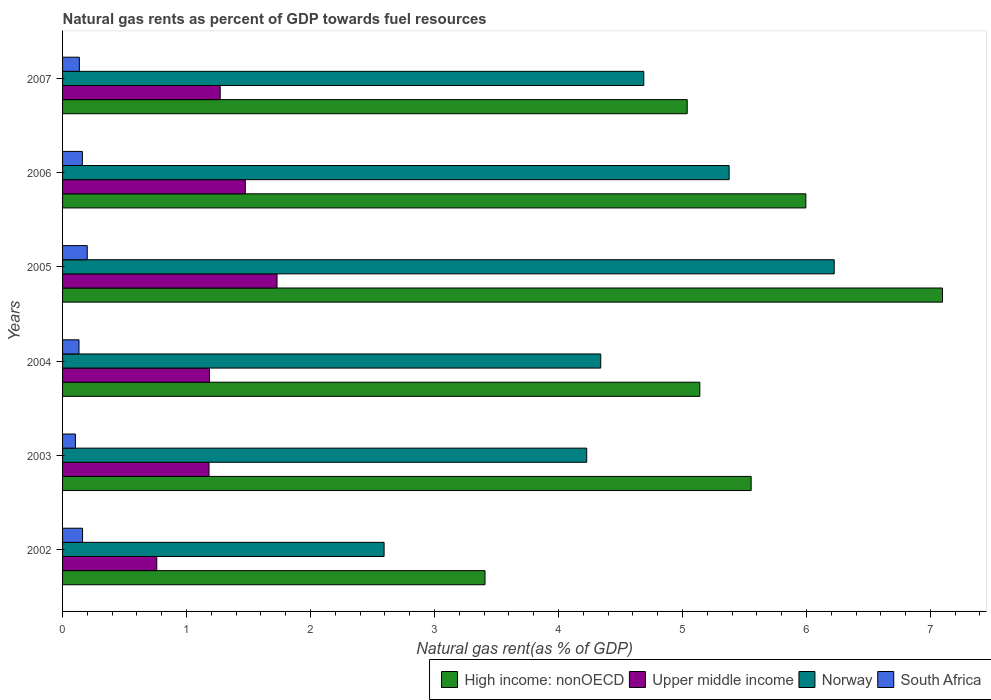How many groups of bars are there?
Make the answer very short. 6. Are the number of bars per tick equal to the number of legend labels?
Your answer should be compact. Yes. How many bars are there on the 6th tick from the top?
Keep it short and to the point. 4. How many bars are there on the 3rd tick from the bottom?
Give a very brief answer. 4. In how many cases, is the number of bars for a given year not equal to the number of legend labels?
Provide a short and direct response. 0. What is the natural gas rent in Norway in 2004?
Make the answer very short. 4.34. Across all years, what is the maximum natural gas rent in South Africa?
Your response must be concise. 0.2. Across all years, what is the minimum natural gas rent in Norway?
Provide a short and direct response. 2.59. In which year was the natural gas rent in Upper middle income maximum?
Provide a succinct answer. 2005. What is the total natural gas rent in Upper middle income in the graph?
Your answer should be compact. 7.6. What is the difference between the natural gas rent in Norway in 2002 and that in 2003?
Provide a succinct answer. -1.63. What is the difference between the natural gas rent in High income: nonOECD in 2004 and the natural gas rent in Norway in 2005?
Provide a succinct answer. -1.08. What is the average natural gas rent in Norway per year?
Make the answer very short. 4.58. In the year 2007, what is the difference between the natural gas rent in High income: nonOECD and natural gas rent in South Africa?
Offer a terse response. 4.9. In how many years, is the natural gas rent in South Africa greater than 2.6 %?
Ensure brevity in your answer.  0. What is the ratio of the natural gas rent in Norway in 2003 to that in 2006?
Provide a succinct answer. 0.79. Is the natural gas rent in Upper middle income in 2002 less than that in 2007?
Give a very brief answer. Yes. Is the difference between the natural gas rent in High income: nonOECD in 2004 and 2006 greater than the difference between the natural gas rent in South Africa in 2004 and 2006?
Provide a short and direct response. No. What is the difference between the highest and the second highest natural gas rent in Upper middle income?
Your answer should be compact. 0.26. What is the difference between the highest and the lowest natural gas rent in Norway?
Provide a succinct answer. 3.63. What does the 1st bar from the top in 2006 represents?
Make the answer very short. South Africa. What does the 1st bar from the bottom in 2003 represents?
Offer a terse response. High income: nonOECD. How many bars are there?
Your answer should be very brief. 24. How many years are there in the graph?
Ensure brevity in your answer.  6. Are the values on the major ticks of X-axis written in scientific E-notation?
Provide a succinct answer. No. Does the graph contain grids?
Make the answer very short. No. How many legend labels are there?
Ensure brevity in your answer.  4. What is the title of the graph?
Your answer should be compact. Natural gas rents as percent of GDP towards fuel resources. What is the label or title of the X-axis?
Offer a terse response. Natural gas rent(as % of GDP). What is the Natural gas rent(as % of GDP) in High income: nonOECD in 2002?
Provide a short and direct response. 3.41. What is the Natural gas rent(as % of GDP) of Upper middle income in 2002?
Your response must be concise. 0.76. What is the Natural gas rent(as % of GDP) of Norway in 2002?
Make the answer very short. 2.59. What is the Natural gas rent(as % of GDP) in South Africa in 2002?
Provide a succinct answer. 0.16. What is the Natural gas rent(as % of GDP) of High income: nonOECD in 2003?
Your answer should be very brief. 5.55. What is the Natural gas rent(as % of GDP) in Upper middle income in 2003?
Make the answer very short. 1.18. What is the Natural gas rent(as % of GDP) of Norway in 2003?
Make the answer very short. 4.23. What is the Natural gas rent(as % of GDP) in South Africa in 2003?
Provide a short and direct response. 0.1. What is the Natural gas rent(as % of GDP) of High income: nonOECD in 2004?
Make the answer very short. 5.14. What is the Natural gas rent(as % of GDP) of Upper middle income in 2004?
Give a very brief answer. 1.19. What is the Natural gas rent(as % of GDP) of Norway in 2004?
Provide a succinct answer. 4.34. What is the Natural gas rent(as % of GDP) of South Africa in 2004?
Offer a very short reply. 0.13. What is the Natural gas rent(as % of GDP) in High income: nonOECD in 2005?
Your response must be concise. 7.1. What is the Natural gas rent(as % of GDP) in Upper middle income in 2005?
Offer a terse response. 1.73. What is the Natural gas rent(as % of GDP) in Norway in 2005?
Provide a short and direct response. 6.22. What is the Natural gas rent(as % of GDP) of South Africa in 2005?
Your answer should be compact. 0.2. What is the Natural gas rent(as % of GDP) in High income: nonOECD in 2006?
Provide a succinct answer. 6. What is the Natural gas rent(as % of GDP) of Upper middle income in 2006?
Make the answer very short. 1.47. What is the Natural gas rent(as % of GDP) of Norway in 2006?
Provide a short and direct response. 5.38. What is the Natural gas rent(as % of GDP) of South Africa in 2006?
Provide a succinct answer. 0.16. What is the Natural gas rent(as % of GDP) of High income: nonOECD in 2007?
Give a very brief answer. 5.04. What is the Natural gas rent(as % of GDP) of Upper middle income in 2007?
Provide a succinct answer. 1.27. What is the Natural gas rent(as % of GDP) of Norway in 2007?
Make the answer very short. 4.69. What is the Natural gas rent(as % of GDP) in South Africa in 2007?
Your answer should be compact. 0.14. Across all years, what is the maximum Natural gas rent(as % of GDP) in High income: nonOECD?
Give a very brief answer. 7.1. Across all years, what is the maximum Natural gas rent(as % of GDP) in Upper middle income?
Offer a very short reply. 1.73. Across all years, what is the maximum Natural gas rent(as % of GDP) of Norway?
Offer a terse response. 6.22. Across all years, what is the maximum Natural gas rent(as % of GDP) of South Africa?
Your response must be concise. 0.2. Across all years, what is the minimum Natural gas rent(as % of GDP) in High income: nonOECD?
Offer a very short reply. 3.41. Across all years, what is the minimum Natural gas rent(as % of GDP) in Upper middle income?
Your response must be concise. 0.76. Across all years, what is the minimum Natural gas rent(as % of GDP) of Norway?
Keep it short and to the point. 2.59. Across all years, what is the minimum Natural gas rent(as % of GDP) of South Africa?
Offer a terse response. 0.1. What is the total Natural gas rent(as % of GDP) of High income: nonOECD in the graph?
Offer a very short reply. 32.23. What is the total Natural gas rent(as % of GDP) of Upper middle income in the graph?
Your answer should be very brief. 7.6. What is the total Natural gas rent(as % of GDP) in Norway in the graph?
Offer a terse response. 27.45. What is the total Natural gas rent(as % of GDP) in South Africa in the graph?
Your answer should be compact. 0.89. What is the difference between the Natural gas rent(as % of GDP) of High income: nonOECD in 2002 and that in 2003?
Provide a succinct answer. -2.15. What is the difference between the Natural gas rent(as % of GDP) of Upper middle income in 2002 and that in 2003?
Ensure brevity in your answer.  -0.42. What is the difference between the Natural gas rent(as % of GDP) of Norway in 2002 and that in 2003?
Provide a succinct answer. -1.63. What is the difference between the Natural gas rent(as % of GDP) in South Africa in 2002 and that in 2003?
Provide a succinct answer. 0.06. What is the difference between the Natural gas rent(as % of GDP) in High income: nonOECD in 2002 and that in 2004?
Ensure brevity in your answer.  -1.73. What is the difference between the Natural gas rent(as % of GDP) of Upper middle income in 2002 and that in 2004?
Ensure brevity in your answer.  -0.43. What is the difference between the Natural gas rent(as % of GDP) of Norway in 2002 and that in 2004?
Provide a succinct answer. -1.75. What is the difference between the Natural gas rent(as % of GDP) of South Africa in 2002 and that in 2004?
Make the answer very short. 0.03. What is the difference between the Natural gas rent(as % of GDP) of High income: nonOECD in 2002 and that in 2005?
Provide a short and direct response. -3.69. What is the difference between the Natural gas rent(as % of GDP) in Upper middle income in 2002 and that in 2005?
Provide a short and direct response. -0.97. What is the difference between the Natural gas rent(as % of GDP) in Norway in 2002 and that in 2005?
Give a very brief answer. -3.63. What is the difference between the Natural gas rent(as % of GDP) of South Africa in 2002 and that in 2005?
Your answer should be very brief. -0.04. What is the difference between the Natural gas rent(as % of GDP) in High income: nonOECD in 2002 and that in 2006?
Offer a very short reply. -2.59. What is the difference between the Natural gas rent(as % of GDP) of Upper middle income in 2002 and that in 2006?
Give a very brief answer. -0.71. What is the difference between the Natural gas rent(as % of GDP) of Norway in 2002 and that in 2006?
Your answer should be very brief. -2.78. What is the difference between the Natural gas rent(as % of GDP) in South Africa in 2002 and that in 2006?
Your answer should be very brief. 0. What is the difference between the Natural gas rent(as % of GDP) of High income: nonOECD in 2002 and that in 2007?
Provide a short and direct response. -1.63. What is the difference between the Natural gas rent(as % of GDP) in Upper middle income in 2002 and that in 2007?
Ensure brevity in your answer.  -0.51. What is the difference between the Natural gas rent(as % of GDP) in Norway in 2002 and that in 2007?
Offer a very short reply. -2.09. What is the difference between the Natural gas rent(as % of GDP) in South Africa in 2002 and that in 2007?
Keep it short and to the point. 0.03. What is the difference between the Natural gas rent(as % of GDP) of High income: nonOECD in 2003 and that in 2004?
Your answer should be very brief. 0.41. What is the difference between the Natural gas rent(as % of GDP) of Upper middle income in 2003 and that in 2004?
Your answer should be very brief. -0. What is the difference between the Natural gas rent(as % of GDP) in Norway in 2003 and that in 2004?
Your answer should be compact. -0.11. What is the difference between the Natural gas rent(as % of GDP) of South Africa in 2003 and that in 2004?
Your answer should be very brief. -0.03. What is the difference between the Natural gas rent(as % of GDP) of High income: nonOECD in 2003 and that in 2005?
Keep it short and to the point. -1.54. What is the difference between the Natural gas rent(as % of GDP) in Upper middle income in 2003 and that in 2005?
Give a very brief answer. -0.55. What is the difference between the Natural gas rent(as % of GDP) of Norway in 2003 and that in 2005?
Provide a succinct answer. -2. What is the difference between the Natural gas rent(as % of GDP) of South Africa in 2003 and that in 2005?
Make the answer very short. -0.1. What is the difference between the Natural gas rent(as % of GDP) of High income: nonOECD in 2003 and that in 2006?
Your answer should be very brief. -0.44. What is the difference between the Natural gas rent(as % of GDP) of Upper middle income in 2003 and that in 2006?
Provide a short and direct response. -0.29. What is the difference between the Natural gas rent(as % of GDP) in Norway in 2003 and that in 2006?
Offer a very short reply. -1.15. What is the difference between the Natural gas rent(as % of GDP) in South Africa in 2003 and that in 2006?
Your answer should be very brief. -0.06. What is the difference between the Natural gas rent(as % of GDP) of High income: nonOECD in 2003 and that in 2007?
Offer a very short reply. 0.52. What is the difference between the Natural gas rent(as % of GDP) of Upper middle income in 2003 and that in 2007?
Provide a short and direct response. -0.09. What is the difference between the Natural gas rent(as % of GDP) in Norway in 2003 and that in 2007?
Keep it short and to the point. -0.46. What is the difference between the Natural gas rent(as % of GDP) in South Africa in 2003 and that in 2007?
Your answer should be very brief. -0.03. What is the difference between the Natural gas rent(as % of GDP) in High income: nonOECD in 2004 and that in 2005?
Provide a succinct answer. -1.96. What is the difference between the Natural gas rent(as % of GDP) of Upper middle income in 2004 and that in 2005?
Offer a terse response. -0.54. What is the difference between the Natural gas rent(as % of GDP) of Norway in 2004 and that in 2005?
Provide a succinct answer. -1.88. What is the difference between the Natural gas rent(as % of GDP) in South Africa in 2004 and that in 2005?
Make the answer very short. -0.07. What is the difference between the Natural gas rent(as % of GDP) in High income: nonOECD in 2004 and that in 2006?
Your answer should be very brief. -0.86. What is the difference between the Natural gas rent(as % of GDP) of Upper middle income in 2004 and that in 2006?
Give a very brief answer. -0.29. What is the difference between the Natural gas rent(as % of GDP) of Norway in 2004 and that in 2006?
Your answer should be compact. -1.04. What is the difference between the Natural gas rent(as % of GDP) of South Africa in 2004 and that in 2006?
Offer a terse response. -0.03. What is the difference between the Natural gas rent(as % of GDP) of High income: nonOECD in 2004 and that in 2007?
Make the answer very short. 0.1. What is the difference between the Natural gas rent(as % of GDP) in Upper middle income in 2004 and that in 2007?
Offer a terse response. -0.09. What is the difference between the Natural gas rent(as % of GDP) in Norway in 2004 and that in 2007?
Provide a short and direct response. -0.35. What is the difference between the Natural gas rent(as % of GDP) in South Africa in 2004 and that in 2007?
Provide a short and direct response. -0. What is the difference between the Natural gas rent(as % of GDP) of High income: nonOECD in 2005 and that in 2006?
Provide a short and direct response. 1.1. What is the difference between the Natural gas rent(as % of GDP) of Upper middle income in 2005 and that in 2006?
Your response must be concise. 0.26. What is the difference between the Natural gas rent(as % of GDP) of Norway in 2005 and that in 2006?
Offer a terse response. 0.85. What is the difference between the Natural gas rent(as % of GDP) in South Africa in 2005 and that in 2006?
Make the answer very short. 0.04. What is the difference between the Natural gas rent(as % of GDP) in High income: nonOECD in 2005 and that in 2007?
Keep it short and to the point. 2.06. What is the difference between the Natural gas rent(as % of GDP) in Upper middle income in 2005 and that in 2007?
Provide a short and direct response. 0.46. What is the difference between the Natural gas rent(as % of GDP) in Norway in 2005 and that in 2007?
Provide a succinct answer. 1.54. What is the difference between the Natural gas rent(as % of GDP) of South Africa in 2005 and that in 2007?
Provide a succinct answer. 0.06. What is the difference between the Natural gas rent(as % of GDP) in Upper middle income in 2006 and that in 2007?
Give a very brief answer. 0.2. What is the difference between the Natural gas rent(as % of GDP) in Norway in 2006 and that in 2007?
Offer a very short reply. 0.69. What is the difference between the Natural gas rent(as % of GDP) in South Africa in 2006 and that in 2007?
Make the answer very short. 0.02. What is the difference between the Natural gas rent(as % of GDP) in High income: nonOECD in 2002 and the Natural gas rent(as % of GDP) in Upper middle income in 2003?
Provide a succinct answer. 2.23. What is the difference between the Natural gas rent(as % of GDP) in High income: nonOECD in 2002 and the Natural gas rent(as % of GDP) in Norway in 2003?
Your answer should be very brief. -0.82. What is the difference between the Natural gas rent(as % of GDP) in High income: nonOECD in 2002 and the Natural gas rent(as % of GDP) in South Africa in 2003?
Offer a terse response. 3.3. What is the difference between the Natural gas rent(as % of GDP) of Upper middle income in 2002 and the Natural gas rent(as % of GDP) of Norway in 2003?
Your answer should be compact. -3.47. What is the difference between the Natural gas rent(as % of GDP) in Upper middle income in 2002 and the Natural gas rent(as % of GDP) in South Africa in 2003?
Keep it short and to the point. 0.66. What is the difference between the Natural gas rent(as % of GDP) of Norway in 2002 and the Natural gas rent(as % of GDP) of South Africa in 2003?
Your response must be concise. 2.49. What is the difference between the Natural gas rent(as % of GDP) of High income: nonOECD in 2002 and the Natural gas rent(as % of GDP) of Upper middle income in 2004?
Keep it short and to the point. 2.22. What is the difference between the Natural gas rent(as % of GDP) of High income: nonOECD in 2002 and the Natural gas rent(as % of GDP) of Norway in 2004?
Your answer should be compact. -0.93. What is the difference between the Natural gas rent(as % of GDP) of High income: nonOECD in 2002 and the Natural gas rent(as % of GDP) of South Africa in 2004?
Your answer should be compact. 3.27. What is the difference between the Natural gas rent(as % of GDP) of Upper middle income in 2002 and the Natural gas rent(as % of GDP) of Norway in 2004?
Your response must be concise. -3.58. What is the difference between the Natural gas rent(as % of GDP) of Upper middle income in 2002 and the Natural gas rent(as % of GDP) of South Africa in 2004?
Give a very brief answer. 0.63. What is the difference between the Natural gas rent(as % of GDP) of Norway in 2002 and the Natural gas rent(as % of GDP) of South Africa in 2004?
Your answer should be very brief. 2.46. What is the difference between the Natural gas rent(as % of GDP) in High income: nonOECD in 2002 and the Natural gas rent(as % of GDP) in Upper middle income in 2005?
Keep it short and to the point. 1.68. What is the difference between the Natural gas rent(as % of GDP) in High income: nonOECD in 2002 and the Natural gas rent(as % of GDP) in Norway in 2005?
Offer a very short reply. -2.82. What is the difference between the Natural gas rent(as % of GDP) in High income: nonOECD in 2002 and the Natural gas rent(as % of GDP) in South Africa in 2005?
Ensure brevity in your answer.  3.21. What is the difference between the Natural gas rent(as % of GDP) in Upper middle income in 2002 and the Natural gas rent(as % of GDP) in Norway in 2005?
Keep it short and to the point. -5.46. What is the difference between the Natural gas rent(as % of GDP) of Upper middle income in 2002 and the Natural gas rent(as % of GDP) of South Africa in 2005?
Provide a succinct answer. 0.56. What is the difference between the Natural gas rent(as % of GDP) of Norway in 2002 and the Natural gas rent(as % of GDP) of South Africa in 2005?
Your response must be concise. 2.39. What is the difference between the Natural gas rent(as % of GDP) in High income: nonOECD in 2002 and the Natural gas rent(as % of GDP) in Upper middle income in 2006?
Offer a terse response. 1.93. What is the difference between the Natural gas rent(as % of GDP) in High income: nonOECD in 2002 and the Natural gas rent(as % of GDP) in Norway in 2006?
Make the answer very short. -1.97. What is the difference between the Natural gas rent(as % of GDP) of High income: nonOECD in 2002 and the Natural gas rent(as % of GDP) of South Africa in 2006?
Offer a very short reply. 3.25. What is the difference between the Natural gas rent(as % of GDP) of Upper middle income in 2002 and the Natural gas rent(as % of GDP) of Norway in 2006?
Keep it short and to the point. -4.62. What is the difference between the Natural gas rent(as % of GDP) of Upper middle income in 2002 and the Natural gas rent(as % of GDP) of South Africa in 2006?
Your answer should be very brief. 0.6. What is the difference between the Natural gas rent(as % of GDP) in Norway in 2002 and the Natural gas rent(as % of GDP) in South Africa in 2006?
Your response must be concise. 2.43. What is the difference between the Natural gas rent(as % of GDP) of High income: nonOECD in 2002 and the Natural gas rent(as % of GDP) of Upper middle income in 2007?
Your answer should be compact. 2.14. What is the difference between the Natural gas rent(as % of GDP) of High income: nonOECD in 2002 and the Natural gas rent(as % of GDP) of Norway in 2007?
Your response must be concise. -1.28. What is the difference between the Natural gas rent(as % of GDP) of High income: nonOECD in 2002 and the Natural gas rent(as % of GDP) of South Africa in 2007?
Make the answer very short. 3.27. What is the difference between the Natural gas rent(as % of GDP) of Upper middle income in 2002 and the Natural gas rent(as % of GDP) of Norway in 2007?
Offer a very short reply. -3.93. What is the difference between the Natural gas rent(as % of GDP) in Upper middle income in 2002 and the Natural gas rent(as % of GDP) in South Africa in 2007?
Ensure brevity in your answer.  0.62. What is the difference between the Natural gas rent(as % of GDP) in Norway in 2002 and the Natural gas rent(as % of GDP) in South Africa in 2007?
Give a very brief answer. 2.46. What is the difference between the Natural gas rent(as % of GDP) of High income: nonOECD in 2003 and the Natural gas rent(as % of GDP) of Upper middle income in 2004?
Your answer should be compact. 4.37. What is the difference between the Natural gas rent(as % of GDP) of High income: nonOECD in 2003 and the Natural gas rent(as % of GDP) of Norway in 2004?
Make the answer very short. 1.21. What is the difference between the Natural gas rent(as % of GDP) of High income: nonOECD in 2003 and the Natural gas rent(as % of GDP) of South Africa in 2004?
Ensure brevity in your answer.  5.42. What is the difference between the Natural gas rent(as % of GDP) of Upper middle income in 2003 and the Natural gas rent(as % of GDP) of Norway in 2004?
Make the answer very short. -3.16. What is the difference between the Natural gas rent(as % of GDP) in Upper middle income in 2003 and the Natural gas rent(as % of GDP) in South Africa in 2004?
Provide a short and direct response. 1.05. What is the difference between the Natural gas rent(as % of GDP) of Norway in 2003 and the Natural gas rent(as % of GDP) of South Africa in 2004?
Give a very brief answer. 4.1. What is the difference between the Natural gas rent(as % of GDP) of High income: nonOECD in 2003 and the Natural gas rent(as % of GDP) of Upper middle income in 2005?
Offer a terse response. 3.82. What is the difference between the Natural gas rent(as % of GDP) of High income: nonOECD in 2003 and the Natural gas rent(as % of GDP) of Norway in 2005?
Your answer should be compact. -0.67. What is the difference between the Natural gas rent(as % of GDP) of High income: nonOECD in 2003 and the Natural gas rent(as % of GDP) of South Africa in 2005?
Offer a very short reply. 5.36. What is the difference between the Natural gas rent(as % of GDP) of Upper middle income in 2003 and the Natural gas rent(as % of GDP) of Norway in 2005?
Give a very brief answer. -5.04. What is the difference between the Natural gas rent(as % of GDP) in Upper middle income in 2003 and the Natural gas rent(as % of GDP) in South Africa in 2005?
Provide a short and direct response. 0.98. What is the difference between the Natural gas rent(as % of GDP) in Norway in 2003 and the Natural gas rent(as % of GDP) in South Africa in 2005?
Make the answer very short. 4.03. What is the difference between the Natural gas rent(as % of GDP) in High income: nonOECD in 2003 and the Natural gas rent(as % of GDP) in Upper middle income in 2006?
Ensure brevity in your answer.  4.08. What is the difference between the Natural gas rent(as % of GDP) in High income: nonOECD in 2003 and the Natural gas rent(as % of GDP) in Norway in 2006?
Your answer should be compact. 0.18. What is the difference between the Natural gas rent(as % of GDP) of High income: nonOECD in 2003 and the Natural gas rent(as % of GDP) of South Africa in 2006?
Provide a short and direct response. 5.39. What is the difference between the Natural gas rent(as % of GDP) in Upper middle income in 2003 and the Natural gas rent(as % of GDP) in Norway in 2006?
Your answer should be compact. -4.2. What is the difference between the Natural gas rent(as % of GDP) of Upper middle income in 2003 and the Natural gas rent(as % of GDP) of South Africa in 2006?
Offer a very short reply. 1.02. What is the difference between the Natural gas rent(as % of GDP) of Norway in 2003 and the Natural gas rent(as % of GDP) of South Africa in 2006?
Ensure brevity in your answer.  4.07. What is the difference between the Natural gas rent(as % of GDP) in High income: nonOECD in 2003 and the Natural gas rent(as % of GDP) in Upper middle income in 2007?
Offer a very short reply. 4.28. What is the difference between the Natural gas rent(as % of GDP) in High income: nonOECD in 2003 and the Natural gas rent(as % of GDP) in Norway in 2007?
Your response must be concise. 0.87. What is the difference between the Natural gas rent(as % of GDP) in High income: nonOECD in 2003 and the Natural gas rent(as % of GDP) in South Africa in 2007?
Your answer should be compact. 5.42. What is the difference between the Natural gas rent(as % of GDP) in Upper middle income in 2003 and the Natural gas rent(as % of GDP) in Norway in 2007?
Ensure brevity in your answer.  -3.51. What is the difference between the Natural gas rent(as % of GDP) in Upper middle income in 2003 and the Natural gas rent(as % of GDP) in South Africa in 2007?
Ensure brevity in your answer.  1.05. What is the difference between the Natural gas rent(as % of GDP) of Norway in 2003 and the Natural gas rent(as % of GDP) of South Africa in 2007?
Your response must be concise. 4.09. What is the difference between the Natural gas rent(as % of GDP) of High income: nonOECD in 2004 and the Natural gas rent(as % of GDP) of Upper middle income in 2005?
Keep it short and to the point. 3.41. What is the difference between the Natural gas rent(as % of GDP) of High income: nonOECD in 2004 and the Natural gas rent(as % of GDP) of Norway in 2005?
Give a very brief answer. -1.08. What is the difference between the Natural gas rent(as % of GDP) of High income: nonOECD in 2004 and the Natural gas rent(as % of GDP) of South Africa in 2005?
Your response must be concise. 4.94. What is the difference between the Natural gas rent(as % of GDP) of Upper middle income in 2004 and the Natural gas rent(as % of GDP) of Norway in 2005?
Offer a terse response. -5.04. What is the difference between the Natural gas rent(as % of GDP) of Upper middle income in 2004 and the Natural gas rent(as % of GDP) of South Africa in 2005?
Give a very brief answer. 0.99. What is the difference between the Natural gas rent(as % of GDP) in Norway in 2004 and the Natural gas rent(as % of GDP) in South Africa in 2005?
Your answer should be compact. 4.14. What is the difference between the Natural gas rent(as % of GDP) in High income: nonOECD in 2004 and the Natural gas rent(as % of GDP) in Upper middle income in 2006?
Your answer should be compact. 3.67. What is the difference between the Natural gas rent(as % of GDP) in High income: nonOECD in 2004 and the Natural gas rent(as % of GDP) in Norway in 2006?
Offer a terse response. -0.24. What is the difference between the Natural gas rent(as % of GDP) of High income: nonOECD in 2004 and the Natural gas rent(as % of GDP) of South Africa in 2006?
Ensure brevity in your answer.  4.98. What is the difference between the Natural gas rent(as % of GDP) in Upper middle income in 2004 and the Natural gas rent(as % of GDP) in Norway in 2006?
Your answer should be very brief. -4.19. What is the difference between the Natural gas rent(as % of GDP) in Upper middle income in 2004 and the Natural gas rent(as % of GDP) in South Africa in 2006?
Give a very brief answer. 1.03. What is the difference between the Natural gas rent(as % of GDP) in Norway in 2004 and the Natural gas rent(as % of GDP) in South Africa in 2006?
Provide a short and direct response. 4.18. What is the difference between the Natural gas rent(as % of GDP) in High income: nonOECD in 2004 and the Natural gas rent(as % of GDP) in Upper middle income in 2007?
Offer a very short reply. 3.87. What is the difference between the Natural gas rent(as % of GDP) of High income: nonOECD in 2004 and the Natural gas rent(as % of GDP) of Norway in 2007?
Provide a succinct answer. 0.45. What is the difference between the Natural gas rent(as % of GDP) of High income: nonOECD in 2004 and the Natural gas rent(as % of GDP) of South Africa in 2007?
Your answer should be very brief. 5. What is the difference between the Natural gas rent(as % of GDP) of Upper middle income in 2004 and the Natural gas rent(as % of GDP) of Norway in 2007?
Offer a very short reply. -3.5. What is the difference between the Natural gas rent(as % of GDP) of Upper middle income in 2004 and the Natural gas rent(as % of GDP) of South Africa in 2007?
Provide a succinct answer. 1.05. What is the difference between the Natural gas rent(as % of GDP) in Norway in 2004 and the Natural gas rent(as % of GDP) in South Africa in 2007?
Your answer should be compact. 4.21. What is the difference between the Natural gas rent(as % of GDP) in High income: nonOECD in 2005 and the Natural gas rent(as % of GDP) in Upper middle income in 2006?
Give a very brief answer. 5.62. What is the difference between the Natural gas rent(as % of GDP) in High income: nonOECD in 2005 and the Natural gas rent(as % of GDP) in Norway in 2006?
Your response must be concise. 1.72. What is the difference between the Natural gas rent(as % of GDP) of High income: nonOECD in 2005 and the Natural gas rent(as % of GDP) of South Africa in 2006?
Offer a terse response. 6.94. What is the difference between the Natural gas rent(as % of GDP) in Upper middle income in 2005 and the Natural gas rent(as % of GDP) in Norway in 2006?
Offer a terse response. -3.65. What is the difference between the Natural gas rent(as % of GDP) in Upper middle income in 2005 and the Natural gas rent(as % of GDP) in South Africa in 2006?
Provide a short and direct response. 1.57. What is the difference between the Natural gas rent(as % of GDP) in Norway in 2005 and the Natural gas rent(as % of GDP) in South Africa in 2006?
Provide a short and direct response. 6.06. What is the difference between the Natural gas rent(as % of GDP) in High income: nonOECD in 2005 and the Natural gas rent(as % of GDP) in Upper middle income in 2007?
Provide a succinct answer. 5.83. What is the difference between the Natural gas rent(as % of GDP) of High income: nonOECD in 2005 and the Natural gas rent(as % of GDP) of Norway in 2007?
Keep it short and to the point. 2.41. What is the difference between the Natural gas rent(as % of GDP) of High income: nonOECD in 2005 and the Natural gas rent(as % of GDP) of South Africa in 2007?
Offer a terse response. 6.96. What is the difference between the Natural gas rent(as % of GDP) of Upper middle income in 2005 and the Natural gas rent(as % of GDP) of Norway in 2007?
Provide a short and direct response. -2.96. What is the difference between the Natural gas rent(as % of GDP) in Upper middle income in 2005 and the Natural gas rent(as % of GDP) in South Africa in 2007?
Provide a short and direct response. 1.59. What is the difference between the Natural gas rent(as % of GDP) of Norway in 2005 and the Natural gas rent(as % of GDP) of South Africa in 2007?
Keep it short and to the point. 6.09. What is the difference between the Natural gas rent(as % of GDP) in High income: nonOECD in 2006 and the Natural gas rent(as % of GDP) in Upper middle income in 2007?
Your answer should be compact. 4.72. What is the difference between the Natural gas rent(as % of GDP) of High income: nonOECD in 2006 and the Natural gas rent(as % of GDP) of Norway in 2007?
Make the answer very short. 1.31. What is the difference between the Natural gas rent(as % of GDP) in High income: nonOECD in 2006 and the Natural gas rent(as % of GDP) in South Africa in 2007?
Your answer should be compact. 5.86. What is the difference between the Natural gas rent(as % of GDP) in Upper middle income in 2006 and the Natural gas rent(as % of GDP) in Norway in 2007?
Provide a succinct answer. -3.21. What is the difference between the Natural gas rent(as % of GDP) of Upper middle income in 2006 and the Natural gas rent(as % of GDP) of South Africa in 2007?
Keep it short and to the point. 1.34. What is the difference between the Natural gas rent(as % of GDP) of Norway in 2006 and the Natural gas rent(as % of GDP) of South Africa in 2007?
Provide a succinct answer. 5.24. What is the average Natural gas rent(as % of GDP) of High income: nonOECD per year?
Give a very brief answer. 5.37. What is the average Natural gas rent(as % of GDP) of Upper middle income per year?
Your answer should be very brief. 1.27. What is the average Natural gas rent(as % of GDP) in Norway per year?
Your answer should be very brief. 4.58. What is the average Natural gas rent(as % of GDP) of South Africa per year?
Give a very brief answer. 0.15. In the year 2002, what is the difference between the Natural gas rent(as % of GDP) in High income: nonOECD and Natural gas rent(as % of GDP) in Upper middle income?
Make the answer very short. 2.65. In the year 2002, what is the difference between the Natural gas rent(as % of GDP) in High income: nonOECD and Natural gas rent(as % of GDP) in Norway?
Provide a succinct answer. 0.81. In the year 2002, what is the difference between the Natural gas rent(as % of GDP) of High income: nonOECD and Natural gas rent(as % of GDP) of South Africa?
Your response must be concise. 3.25. In the year 2002, what is the difference between the Natural gas rent(as % of GDP) in Upper middle income and Natural gas rent(as % of GDP) in Norway?
Give a very brief answer. -1.83. In the year 2002, what is the difference between the Natural gas rent(as % of GDP) in Upper middle income and Natural gas rent(as % of GDP) in South Africa?
Your answer should be very brief. 0.6. In the year 2002, what is the difference between the Natural gas rent(as % of GDP) in Norway and Natural gas rent(as % of GDP) in South Africa?
Offer a very short reply. 2.43. In the year 2003, what is the difference between the Natural gas rent(as % of GDP) of High income: nonOECD and Natural gas rent(as % of GDP) of Upper middle income?
Your answer should be compact. 4.37. In the year 2003, what is the difference between the Natural gas rent(as % of GDP) in High income: nonOECD and Natural gas rent(as % of GDP) in Norway?
Ensure brevity in your answer.  1.33. In the year 2003, what is the difference between the Natural gas rent(as % of GDP) of High income: nonOECD and Natural gas rent(as % of GDP) of South Africa?
Provide a succinct answer. 5.45. In the year 2003, what is the difference between the Natural gas rent(as % of GDP) of Upper middle income and Natural gas rent(as % of GDP) of Norway?
Give a very brief answer. -3.05. In the year 2003, what is the difference between the Natural gas rent(as % of GDP) in Upper middle income and Natural gas rent(as % of GDP) in South Africa?
Make the answer very short. 1.08. In the year 2003, what is the difference between the Natural gas rent(as % of GDP) of Norway and Natural gas rent(as % of GDP) of South Africa?
Keep it short and to the point. 4.12. In the year 2004, what is the difference between the Natural gas rent(as % of GDP) of High income: nonOECD and Natural gas rent(as % of GDP) of Upper middle income?
Make the answer very short. 3.95. In the year 2004, what is the difference between the Natural gas rent(as % of GDP) in High income: nonOECD and Natural gas rent(as % of GDP) in Norway?
Provide a short and direct response. 0.8. In the year 2004, what is the difference between the Natural gas rent(as % of GDP) in High income: nonOECD and Natural gas rent(as % of GDP) in South Africa?
Make the answer very short. 5.01. In the year 2004, what is the difference between the Natural gas rent(as % of GDP) of Upper middle income and Natural gas rent(as % of GDP) of Norway?
Ensure brevity in your answer.  -3.16. In the year 2004, what is the difference between the Natural gas rent(as % of GDP) of Upper middle income and Natural gas rent(as % of GDP) of South Africa?
Make the answer very short. 1.05. In the year 2004, what is the difference between the Natural gas rent(as % of GDP) of Norway and Natural gas rent(as % of GDP) of South Africa?
Make the answer very short. 4.21. In the year 2005, what is the difference between the Natural gas rent(as % of GDP) of High income: nonOECD and Natural gas rent(as % of GDP) of Upper middle income?
Your answer should be very brief. 5.37. In the year 2005, what is the difference between the Natural gas rent(as % of GDP) of High income: nonOECD and Natural gas rent(as % of GDP) of Norway?
Offer a terse response. 0.87. In the year 2005, what is the difference between the Natural gas rent(as % of GDP) in High income: nonOECD and Natural gas rent(as % of GDP) in South Africa?
Offer a terse response. 6.9. In the year 2005, what is the difference between the Natural gas rent(as % of GDP) in Upper middle income and Natural gas rent(as % of GDP) in Norway?
Provide a short and direct response. -4.49. In the year 2005, what is the difference between the Natural gas rent(as % of GDP) of Upper middle income and Natural gas rent(as % of GDP) of South Africa?
Your answer should be compact. 1.53. In the year 2005, what is the difference between the Natural gas rent(as % of GDP) in Norway and Natural gas rent(as % of GDP) in South Africa?
Provide a succinct answer. 6.03. In the year 2006, what is the difference between the Natural gas rent(as % of GDP) in High income: nonOECD and Natural gas rent(as % of GDP) in Upper middle income?
Keep it short and to the point. 4.52. In the year 2006, what is the difference between the Natural gas rent(as % of GDP) of High income: nonOECD and Natural gas rent(as % of GDP) of Norway?
Your response must be concise. 0.62. In the year 2006, what is the difference between the Natural gas rent(as % of GDP) in High income: nonOECD and Natural gas rent(as % of GDP) in South Africa?
Give a very brief answer. 5.84. In the year 2006, what is the difference between the Natural gas rent(as % of GDP) of Upper middle income and Natural gas rent(as % of GDP) of Norway?
Ensure brevity in your answer.  -3.9. In the year 2006, what is the difference between the Natural gas rent(as % of GDP) of Upper middle income and Natural gas rent(as % of GDP) of South Africa?
Give a very brief answer. 1.31. In the year 2006, what is the difference between the Natural gas rent(as % of GDP) in Norway and Natural gas rent(as % of GDP) in South Africa?
Your answer should be compact. 5.22. In the year 2007, what is the difference between the Natural gas rent(as % of GDP) in High income: nonOECD and Natural gas rent(as % of GDP) in Upper middle income?
Give a very brief answer. 3.77. In the year 2007, what is the difference between the Natural gas rent(as % of GDP) of High income: nonOECD and Natural gas rent(as % of GDP) of Norway?
Give a very brief answer. 0.35. In the year 2007, what is the difference between the Natural gas rent(as % of GDP) in High income: nonOECD and Natural gas rent(as % of GDP) in South Africa?
Keep it short and to the point. 4.9. In the year 2007, what is the difference between the Natural gas rent(as % of GDP) of Upper middle income and Natural gas rent(as % of GDP) of Norway?
Offer a terse response. -3.42. In the year 2007, what is the difference between the Natural gas rent(as % of GDP) in Upper middle income and Natural gas rent(as % of GDP) in South Africa?
Give a very brief answer. 1.14. In the year 2007, what is the difference between the Natural gas rent(as % of GDP) of Norway and Natural gas rent(as % of GDP) of South Africa?
Keep it short and to the point. 4.55. What is the ratio of the Natural gas rent(as % of GDP) of High income: nonOECD in 2002 to that in 2003?
Your answer should be very brief. 0.61. What is the ratio of the Natural gas rent(as % of GDP) of Upper middle income in 2002 to that in 2003?
Offer a very short reply. 0.64. What is the ratio of the Natural gas rent(as % of GDP) of Norway in 2002 to that in 2003?
Your answer should be compact. 0.61. What is the ratio of the Natural gas rent(as % of GDP) of South Africa in 2002 to that in 2003?
Keep it short and to the point. 1.56. What is the ratio of the Natural gas rent(as % of GDP) in High income: nonOECD in 2002 to that in 2004?
Give a very brief answer. 0.66. What is the ratio of the Natural gas rent(as % of GDP) of Upper middle income in 2002 to that in 2004?
Offer a very short reply. 0.64. What is the ratio of the Natural gas rent(as % of GDP) of Norway in 2002 to that in 2004?
Your response must be concise. 0.6. What is the ratio of the Natural gas rent(as % of GDP) of South Africa in 2002 to that in 2004?
Provide a short and direct response. 1.22. What is the ratio of the Natural gas rent(as % of GDP) of High income: nonOECD in 2002 to that in 2005?
Keep it short and to the point. 0.48. What is the ratio of the Natural gas rent(as % of GDP) of Upper middle income in 2002 to that in 2005?
Provide a succinct answer. 0.44. What is the ratio of the Natural gas rent(as % of GDP) in Norway in 2002 to that in 2005?
Ensure brevity in your answer.  0.42. What is the ratio of the Natural gas rent(as % of GDP) of South Africa in 2002 to that in 2005?
Keep it short and to the point. 0.81. What is the ratio of the Natural gas rent(as % of GDP) in High income: nonOECD in 2002 to that in 2006?
Make the answer very short. 0.57. What is the ratio of the Natural gas rent(as % of GDP) in Upper middle income in 2002 to that in 2006?
Your answer should be very brief. 0.52. What is the ratio of the Natural gas rent(as % of GDP) in Norway in 2002 to that in 2006?
Your response must be concise. 0.48. What is the ratio of the Natural gas rent(as % of GDP) in South Africa in 2002 to that in 2006?
Offer a terse response. 1.01. What is the ratio of the Natural gas rent(as % of GDP) of High income: nonOECD in 2002 to that in 2007?
Provide a succinct answer. 0.68. What is the ratio of the Natural gas rent(as % of GDP) in Upper middle income in 2002 to that in 2007?
Offer a very short reply. 0.6. What is the ratio of the Natural gas rent(as % of GDP) of Norway in 2002 to that in 2007?
Keep it short and to the point. 0.55. What is the ratio of the Natural gas rent(as % of GDP) in South Africa in 2002 to that in 2007?
Provide a short and direct response. 1.19. What is the ratio of the Natural gas rent(as % of GDP) in High income: nonOECD in 2003 to that in 2004?
Your answer should be very brief. 1.08. What is the ratio of the Natural gas rent(as % of GDP) of Upper middle income in 2003 to that in 2004?
Give a very brief answer. 1. What is the ratio of the Natural gas rent(as % of GDP) of Norway in 2003 to that in 2004?
Keep it short and to the point. 0.97. What is the ratio of the Natural gas rent(as % of GDP) of South Africa in 2003 to that in 2004?
Give a very brief answer. 0.78. What is the ratio of the Natural gas rent(as % of GDP) of High income: nonOECD in 2003 to that in 2005?
Offer a very short reply. 0.78. What is the ratio of the Natural gas rent(as % of GDP) of Upper middle income in 2003 to that in 2005?
Your response must be concise. 0.68. What is the ratio of the Natural gas rent(as % of GDP) in Norway in 2003 to that in 2005?
Ensure brevity in your answer.  0.68. What is the ratio of the Natural gas rent(as % of GDP) of South Africa in 2003 to that in 2005?
Your answer should be very brief. 0.52. What is the ratio of the Natural gas rent(as % of GDP) of High income: nonOECD in 2003 to that in 2006?
Make the answer very short. 0.93. What is the ratio of the Natural gas rent(as % of GDP) of Upper middle income in 2003 to that in 2006?
Your answer should be very brief. 0.8. What is the ratio of the Natural gas rent(as % of GDP) in Norway in 2003 to that in 2006?
Ensure brevity in your answer.  0.79. What is the ratio of the Natural gas rent(as % of GDP) in South Africa in 2003 to that in 2006?
Your response must be concise. 0.65. What is the ratio of the Natural gas rent(as % of GDP) of High income: nonOECD in 2003 to that in 2007?
Make the answer very short. 1.1. What is the ratio of the Natural gas rent(as % of GDP) of Upper middle income in 2003 to that in 2007?
Your answer should be very brief. 0.93. What is the ratio of the Natural gas rent(as % of GDP) of Norway in 2003 to that in 2007?
Offer a very short reply. 0.9. What is the ratio of the Natural gas rent(as % of GDP) of South Africa in 2003 to that in 2007?
Your response must be concise. 0.76. What is the ratio of the Natural gas rent(as % of GDP) of High income: nonOECD in 2004 to that in 2005?
Give a very brief answer. 0.72. What is the ratio of the Natural gas rent(as % of GDP) of Upper middle income in 2004 to that in 2005?
Keep it short and to the point. 0.69. What is the ratio of the Natural gas rent(as % of GDP) of Norway in 2004 to that in 2005?
Provide a succinct answer. 0.7. What is the ratio of the Natural gas rent(as % of GDP) in South Africa in 2004 to that in 2005?
Keep it short and to the point. 0.67. What is the ratio of the Natural gas rent(as % of GDP) in High income: nonOECD in 2004 to that in 2006?
Offer a very short reply. 0.86. What is the ratio of the Natural gas rent(as % of GDP) of Upper middle income in 2004 to that in 2006?
Make the answer very short. 0.8. What is the ratio of the Natural gas rent(as % of GDP) in Norway in 2004 to that in 2006?
Offer a very short reply. 0.81. What is the ratio of the Natural gas rent(as % of GDP) of South Africa in 2004 to that in 2006?
Make the answer very short. 0.83. What is the ratio of the Natural gas rent(as % of GDP) in High income: nonOECD in 2004 to that in 2007?
Ensure brevity in your answer.  1.02. What is the ratio of the Natural gas rent(as % of GDP) in Upper middle income in 2004 to that in 2007?
Provide a succinct answer. 0.93. What is the ratio of the Natural gas rent(as % of GDP) of Norway in 2004 to that in 2007?
Offer a very short reply. 0.93. What is the ratio of the Natural gas rent(as % of GDP) of South Africa in 2004 to that in 2007?
Make the answer very short. 0.98. What is the ratio of the Natural gas rent(as % of GDP) in High income: nonOECD in 2005 to that in 2006?
Keep it short and to the point. 1.18. What is the ratio of the Natural gas rent(as % of GDP) of Upper middle income in 2005 to that in 2006?
Your answer should be compact. 1.17. What is the ratio of the Natural gas rent(as % of GDP) in Norway in 2005 to that in 2006?
Give a very brief answer. 1.16. What is the ratio of the Natural gas rent(as % of GDP) in South Africa in 2005 to that in 2006?
Give a very brief answer. 1.25. What is the ratio of the Natural gas rent(as % of GDP) of High income: nonOECD in 2005 to that in 2007?
Offer a terse response. 1.41. What is the ratio of the Natural gas rent(as % of GDP) in Upper middle income in 2005 to that in 2007?
Keep it short and to the point. 1.36. What is the ratio of the Natural gas rent(as % of GDP) in Norway in 2005 to that in 2007?
Make the answer very short. 1.33. What is the ratio of the Natural gas rent(as % of GDP) in South Africa in 2005 to that in 2007?
Provide a short and direct response. 1.47. What is the ratio of the Natural gas rent(as % of GDP) in High income: nonOECD in 2006 to that in 2007?
Ensure brevity in your answer.  1.19. What is the ratio of the Natural gas rent(as % of GDP) of Upper middle income in 2006 to that in 2007?
Ensure brevity in your answer.  1.16. What is the ratio of the Natural gas rent(as % of GDP) of Norway in 2006 to that in 2007?
Offer a terse response. 1.15. What is the ratio of the Natural gas rent(as % of GDP) of South Africa in 2006 to that in 2007?
Give a very brief answer. 1.18. What is the difference between the highest and the second highest Natural gas rent(as % of GDP) in High income: nonOECD?
Your response must be concise. 1.1. What is the difference between the highest and the second highest Natural gas rent(as % of GDP) of Upper middle income?
Your answer should be very brief. 0.26. What is the difference between the highest and the second highest Natural gas rent(as % of GDP) in Norway?
Keep it short and to the point. 0.85. What is the difference between the highest and the second highest Natural gas rent(as % of GDP) of South Africa?
Your answer should be compact. 0.04. What is the difference between the highest and the lowest Natural gas rent(as % of GDP) in High income: nonOECD?
Provide a short and direct response. 3.69. What is the difference between the highest and the lowest Natural gas rent(as % of GDP) of Norway?
Offer a very short reply. 3.63. What is the difference between the highest and the lowest Natural gas rent(as % of GDP) of South Africa?
Your answer should be very brief. 0.1. 